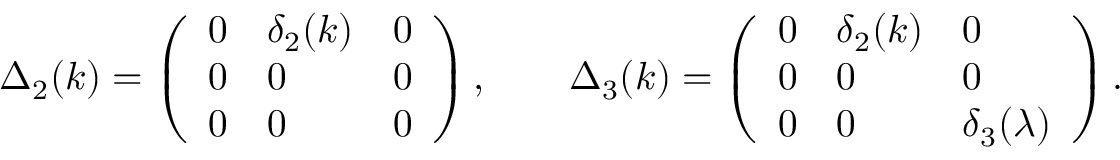<formula> <loc_0><loc_0><loc_500><loc_500>\begin{array} { r } { \Delta _ { 2 } ( k ) = \left ( \begin{array} { l l l } { 0 } & { \delta _ { 2 } ( k ) } & { 0 } \\ { 0 } & { 0 } & { 0 } \\ { 0 } & { 0 } & { 0 } \end{array} \right ) , \quad \Delta _ { 3 } ( k ) = \left ( \begin{array} { l l l } { 0 } & { \delta _ { 2 } ( k ) } & { 0 } \\ { 0 } & { 0 } & { 0 } \\ { 0 } & { 0 } & { \delta _ { 3 } ( \lambda ) } \end{array} \right ) . } \end{array}</formula> 